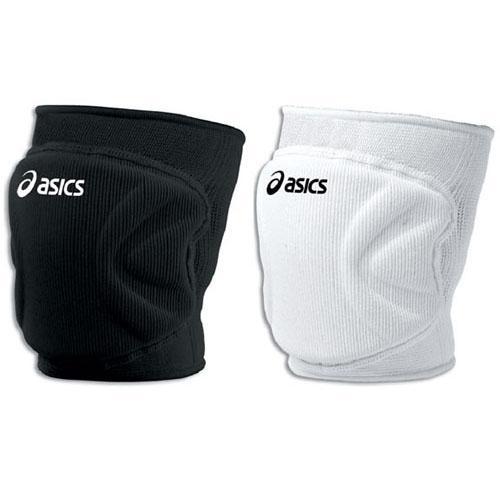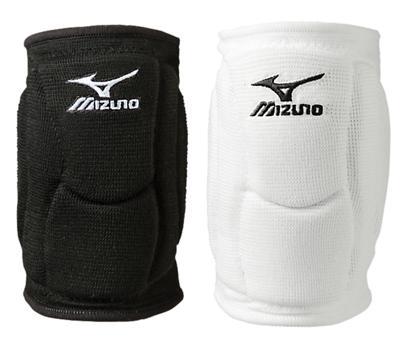The first image is the image on the left, the second image is the image on the right. Given the left and right images, does the statement "Three pads are black and one is white." hold true? Answer yes or no. No. The first image is the image on the left, the second image is the image on the right. Assess this claim about the two images: "The white object is on the right side of the image in the image on the right.". Correct or not? Answer yes or no. Yes. 